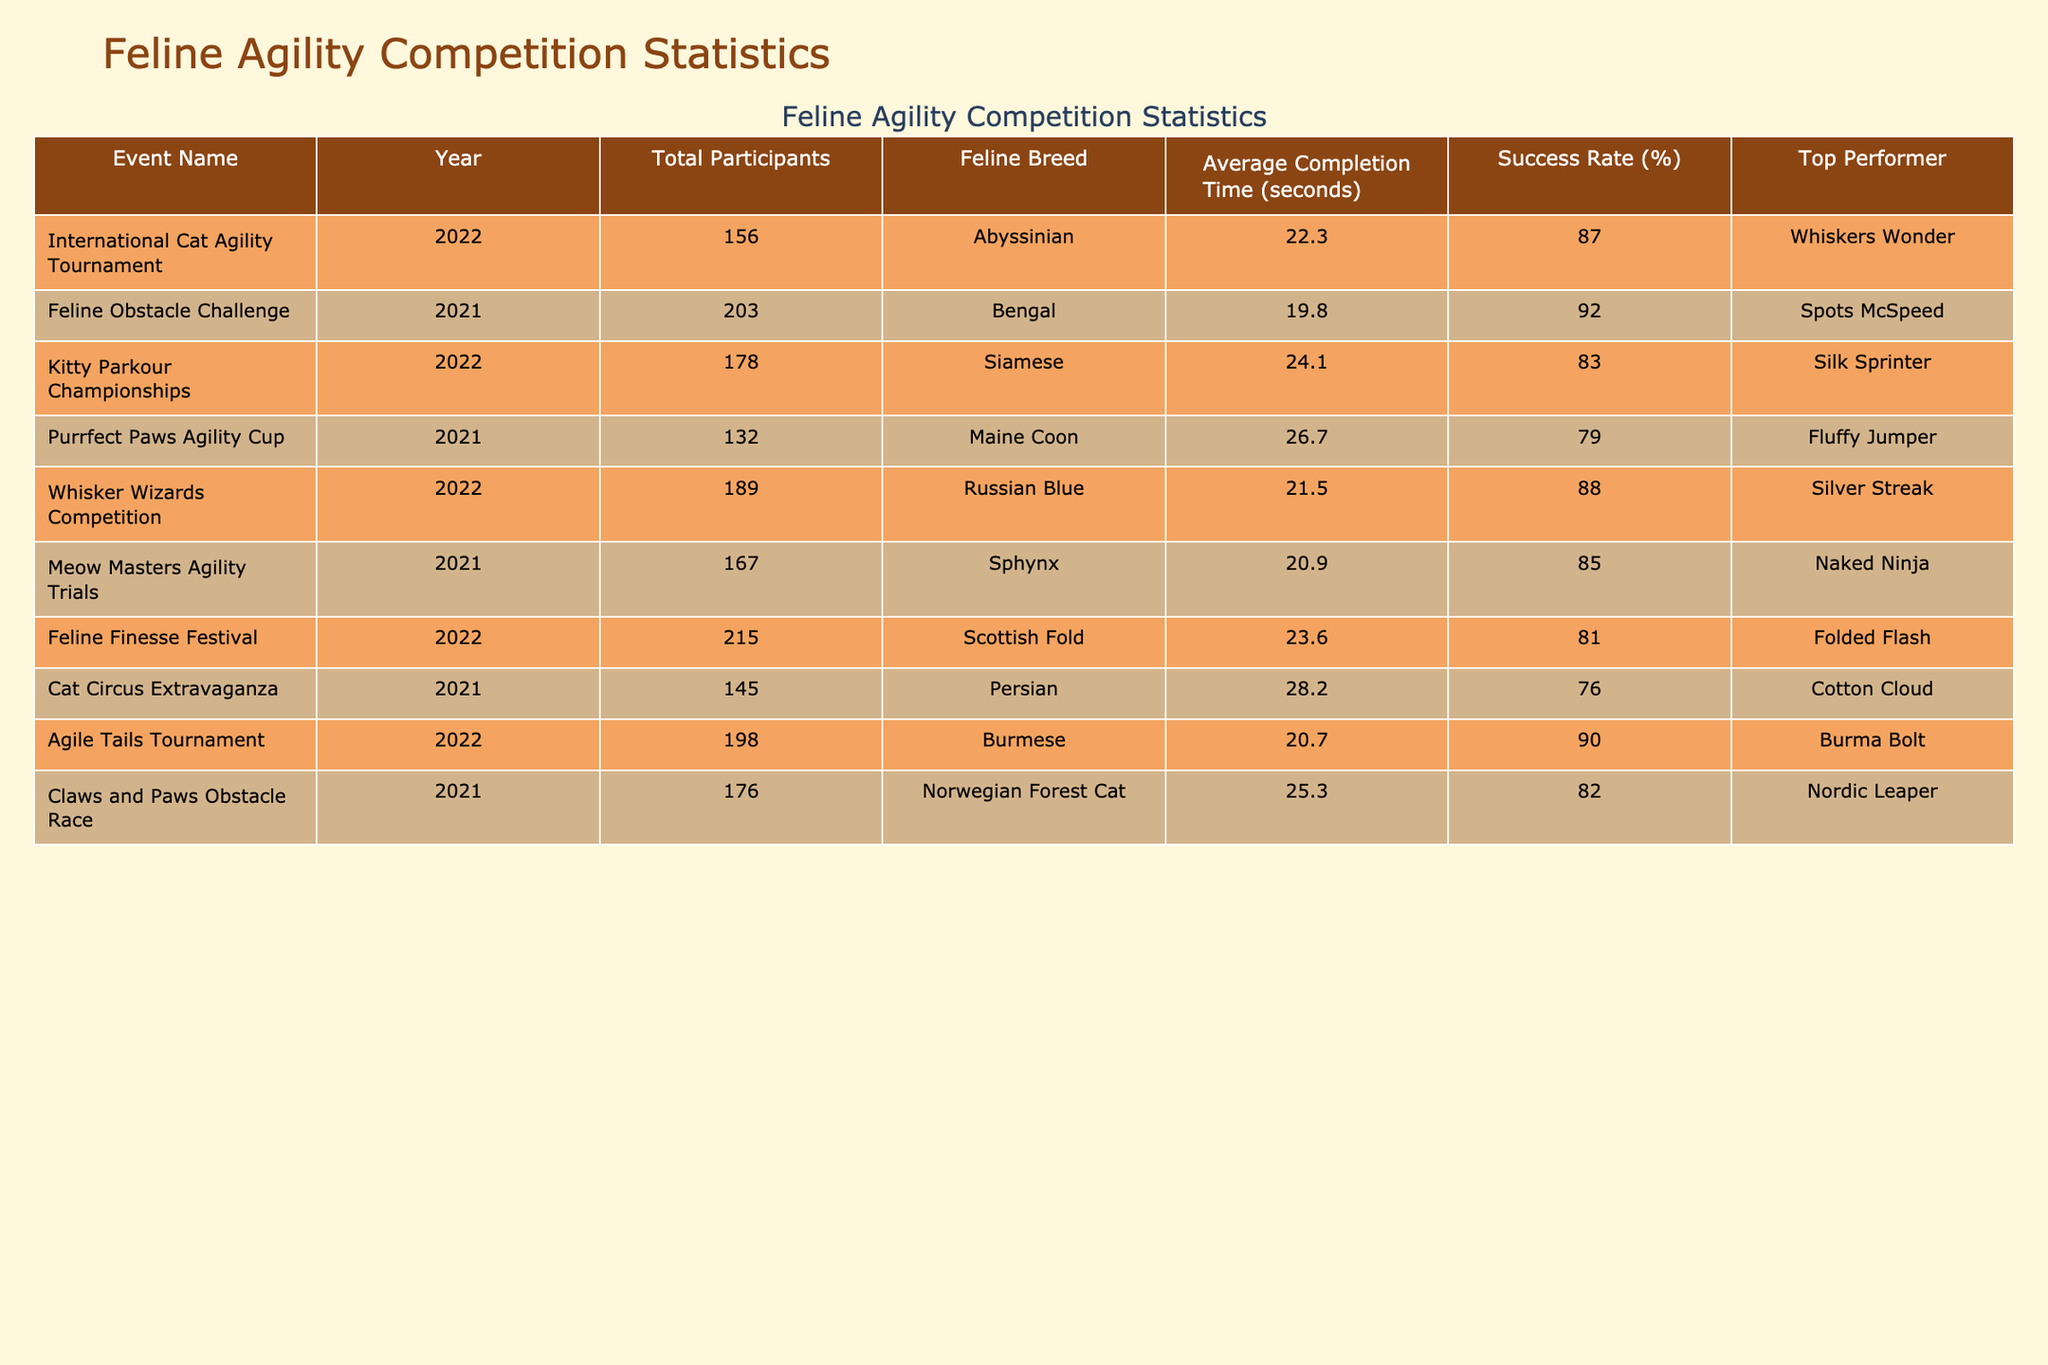What is the average completion time for the Abyssinian breed in the 2022 International Cat Agility Tournament? The table shows that the Abyssinian breed had an average completion time of 22.3 seconds listed under the International Cat Agility Tournament for the year 2022.
Answer: 22.3 seconds Which feline breed had the highest success rate in 2021? By examining the success rates in 2021, the Bengal breed from the Feline Obstacle Challenge displayed the highest success rate of 92%.
Answer: Bengal What is the total number of participants across all events in 2022? To find the total, add the participants from each 2022 event: 156 (International Cat Agility Tournament) + 178 (Kitty Parkour Championships) + 189 (Whisker Wizards Competition) + 215 (Feline Finesse Festival) + 198 (Agile Tails Tournament) = 1036 participants.
Answer: 1036 participants Did the Persian breed achieve a success rate above 80% in 2021? The success rate for the Persian breed in the Cat Circus Extravaganza in 2021 is 76%, which is below 80%. Therefore, the statement is false.
Answer: No What is the average completion time for the top three performers in terms of completion time in 2022? The top three performers based on completion time for 2022 are: Agile Tails Tournament (20.7 seconds), Whisker Wizards Competition (21.5 seconds), and International Cat Agility Tournament (22.3 seconds). The average is (20.7 + 21.5 + 22.3) / 3 = 21.5 seconds.
Answer: 21.5 seconds Which event had the highest total participation in 2021? The event with the highest participation in 2021 is the Feline Obstacle Challenge, with a total of 203 participants, as indicated in the table.
Answer: Feline Obstacle Challenge How many events had a success rate of 85% or higher in 2022? Reviewing the events from 2022, the Whisker Wizards Competition (88%), Agile Tails Tournament (90%), Feline Finesse Festival (81%), and the International Cat Agility Tournament (87%) had success rates of 85% or higher. This totals to 4 events.
Answer: 4 events What is the difference in average completion time between the highest and lowest performing event in 2021? In 2021, the highest performing event in terms of the lowest average completion time is the Feline Obstacle Challenge with 19.8 seconds, and the lowest is the Cat Circus Extravaganza with 28.2 seconds. The difference is 28.2 - 19.8 = 8.4 seconds.
Answer: 8.4 seconds Which event had the top performer with the name "Burma Bolt"? The top performer named "Burma Bolt" is associated with the Agile Tails Tournament in 2022, as stated in the table.
Answer: Agile Tails Tournament 